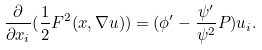Convert formula to latex. <formula><loc_0><loc_0><loc_500><loc_500>\frac { \partial } { \partial x _ { i } } ( \frac { 1 } { 2 } F ^ { 2 } ( x , \nabla u ) ) = ( \phi ^ { \prime } - \frac { \psi ^ { \prime } } { \psi ^ { 2 } } P ) u _ { i } .</formula> 